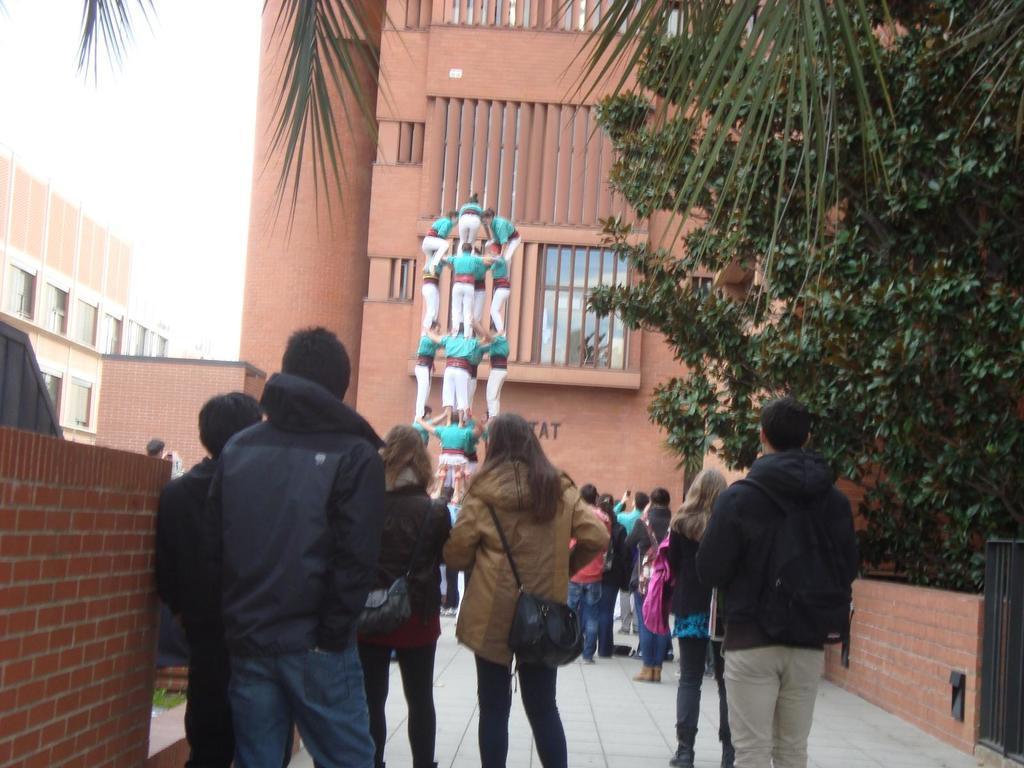Describe this image in one or two sentences. In this image I can see the ground, number of persons standing on the ground, few walls which are made up of bricks, a metal gate, few trees which are green in color, few persons standing on each other and few buildings which are brown in color. In the background I can see the sky. 